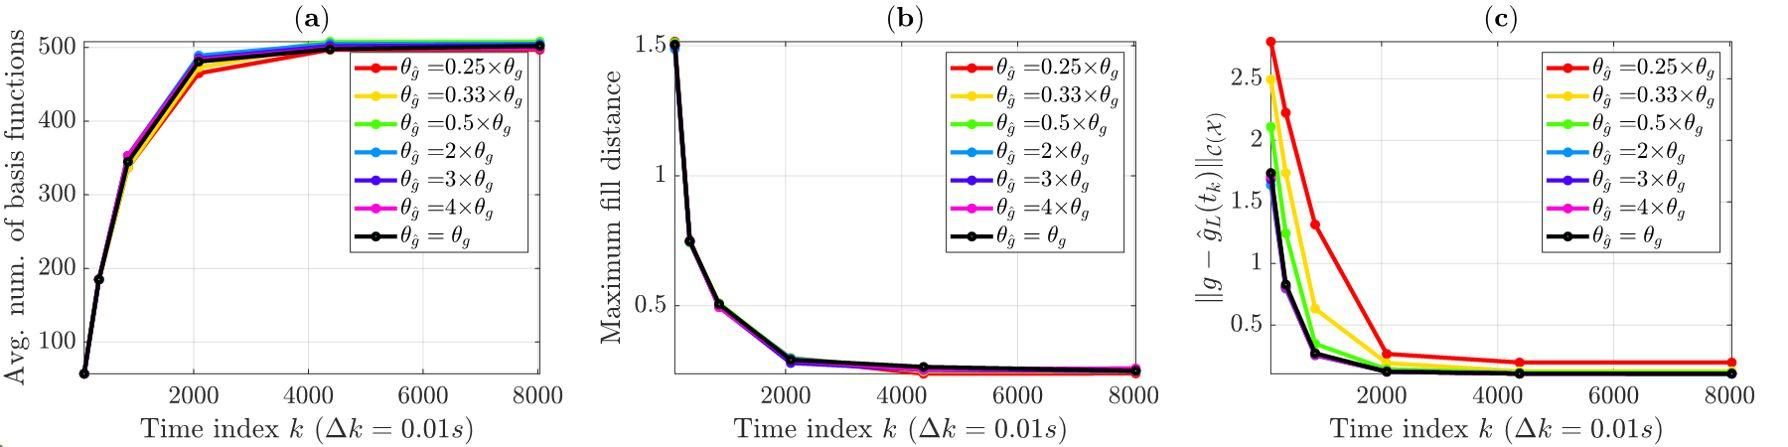Based on figure (b), what can be inferred about the maximum fill distance over time? A. The maximum fill distance increases over time. B. The maximum fill distance decreases and then increases over time. C. The maximum fill distance decreases over time. D. The maximum fill distance remains constant over time. Analyzing figure (b), we observe a clear trend where the maximum fill distance initially undergoes a rapid decrease followed by a stabilization at a minimal value across all values of 	heta_j. This behavior suggests that over time, the system reaches a stable state where the fill distance no longer changes significantly. Hence, the best answer is C: The maximum fill distance decreases over time. 